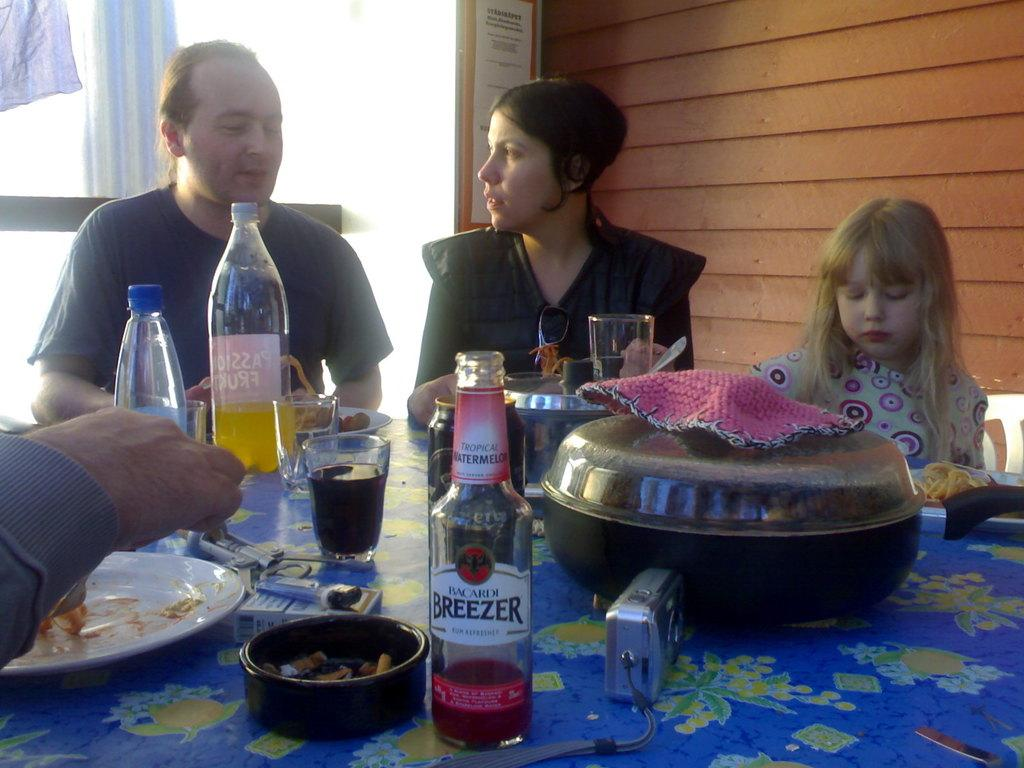How many people are sitting at the dining table in the image? There are three people sitting at the dining table in the image. What can be seen on the left side of the table? There is a bottle on the left side of the table. Can you describe the surroundings of the dining table? There is a glass wall in the image. What type of coach is present in the image to help the beginner learn how to use the worm? There is no coach, beginner, or worm present in the image. 